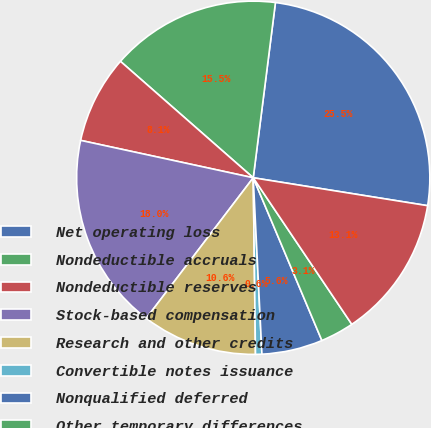Convert chart. <chart><loc_0><loc_0><loc_500><loc_500><pie_chart><fcel>Net operating loss<fcel>Nondeductible accruals<fcel>Nondeductible reserves<fcel>Stock-based compensation<fcel>Research and other credits<fcel>Convertible notes issuance<fcel>Nonqualified deferred<fcel>Other temporary differences<fcel>Less valuation allowance<nl><fcel>25.52%<fcel>15.55%<fcel>8.06%<fcel>18.04%<fcel>10.56%<fcel>0.58%<fcel>5.57%<fcel>3.07%<fcel>13.05%<nl></chart> 